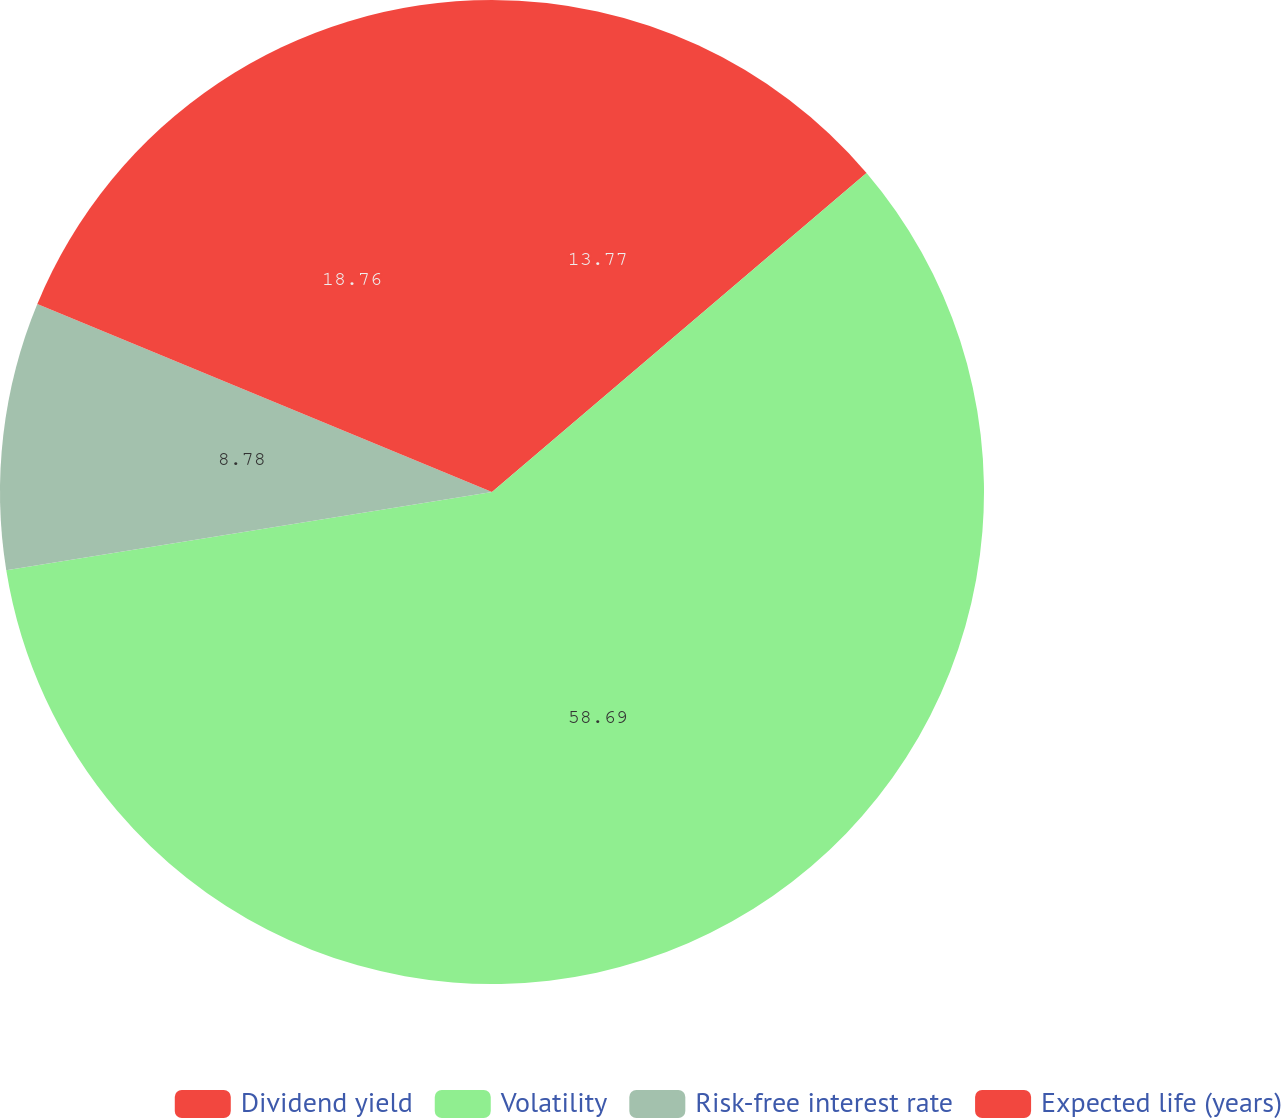Convert chart to OTSL. <chart><loc_0><loc_0><loc_500><loc_500><pie_chart><fcel>Dividend yield<fcel>Volatility<fcel>Risk-free interest rate<fcel>Expected life (years)<nl><fcel>13.77%<fcel>58.68%<fcel>8.78%<fcel>18.76%<nl></chart> 